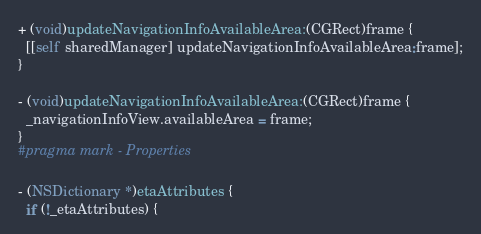Convert code to text. <code><loc_0><loc_0><loc_500><loc_500><_ObjectiveC_>+ (void)updateNavigationInfoAvailableArea:(CGRect)frame {
  [[self sharedManager] updateNavigationInfoAvailableArea:frame];
}

- (void)updateNavigationInfoAvailableArea:(CGRect)frame {
  _navigationInfoView.availableArea = frame;
}
#pragma mark - Properties

- (NSDictionary *)etaAttributes {
  if (!_etaAttributes) {</code> 